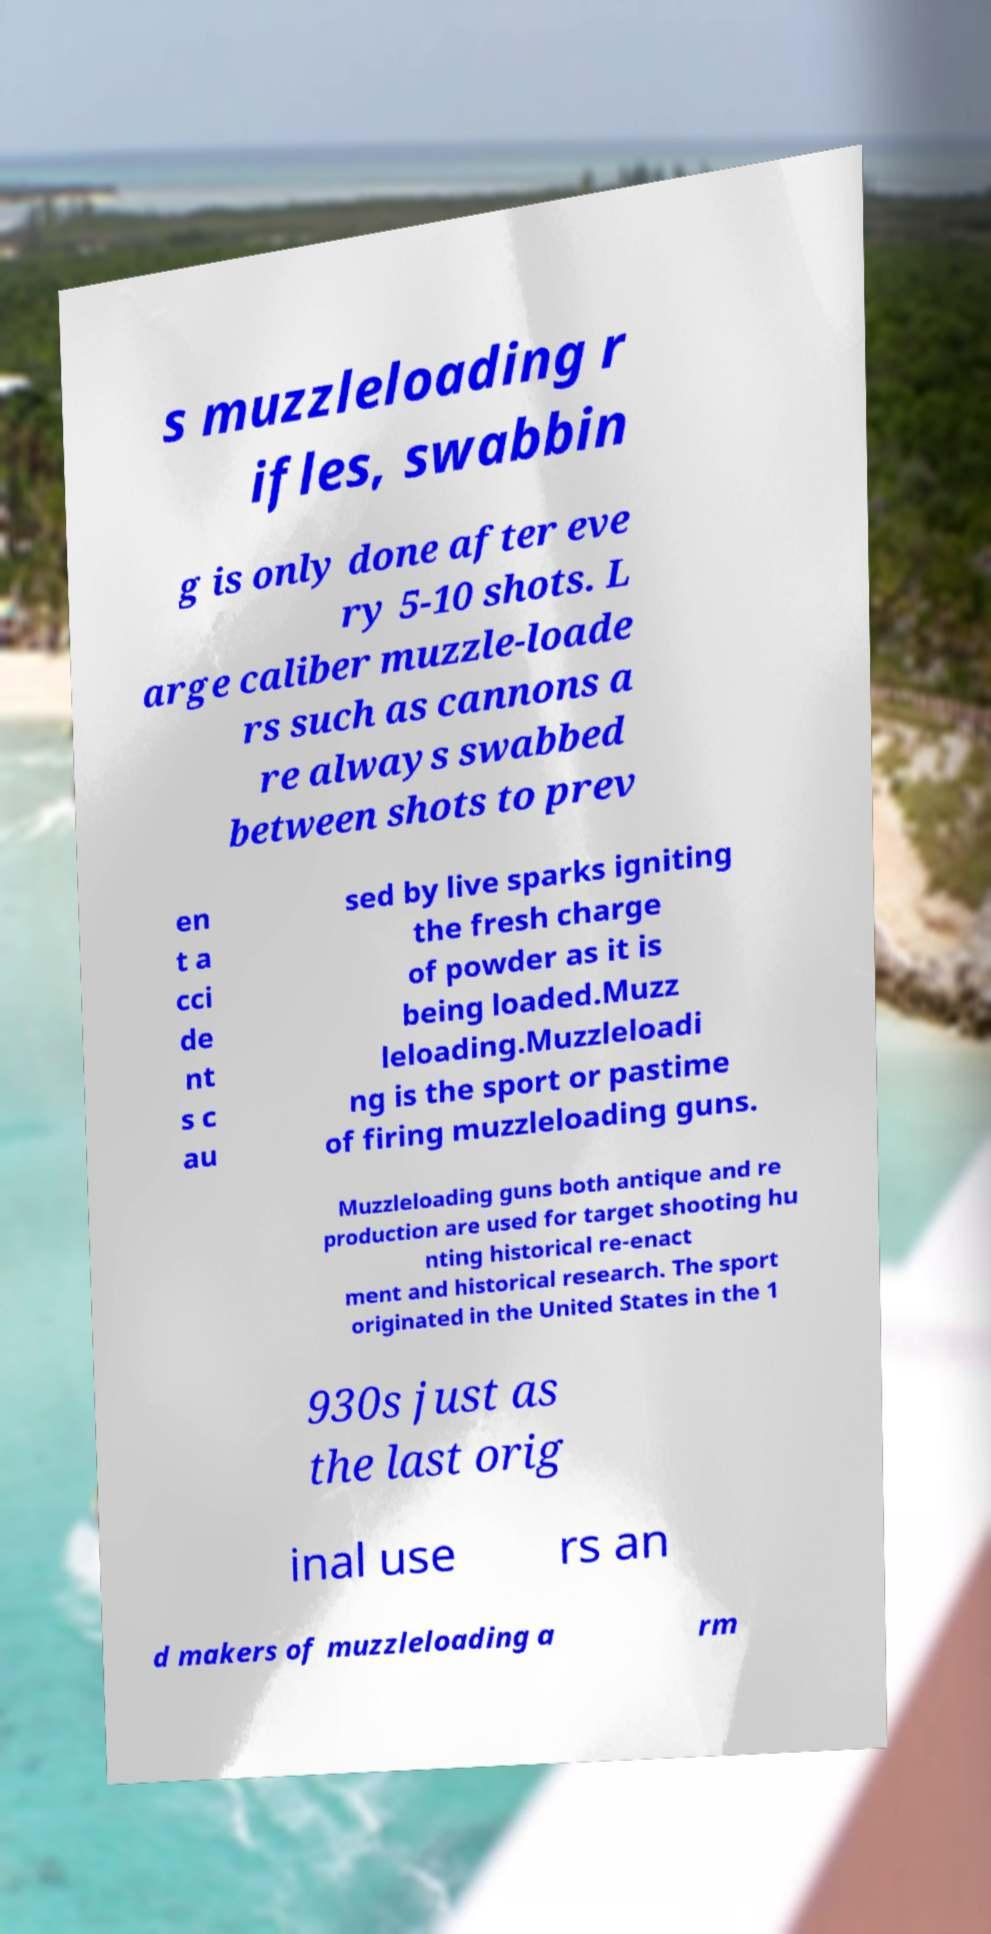For documentation purposes, I need the text within this image transcribed. Could you provide that? s muzzleloading r ifles, swabbin g is only done after eve ry 5-10 shots. L arge caliber muzzle-loade rs such as cannons a re always swabbed between shots to prev en t a cci de nt s c au sed by live sparks igniting the fresh charge of powder as it is being loaded.Muzz leloading.Muzzleloadi ng is the sport or pastime of firing muzzleloading guns. Muzzleloading guns both antique and re production are used for target shooting hu nting historical re-enact ment and historical research. The sport originated in the United States in the 1 930s just as the last orig inal use rs an d makers of muzzleloading a rm 